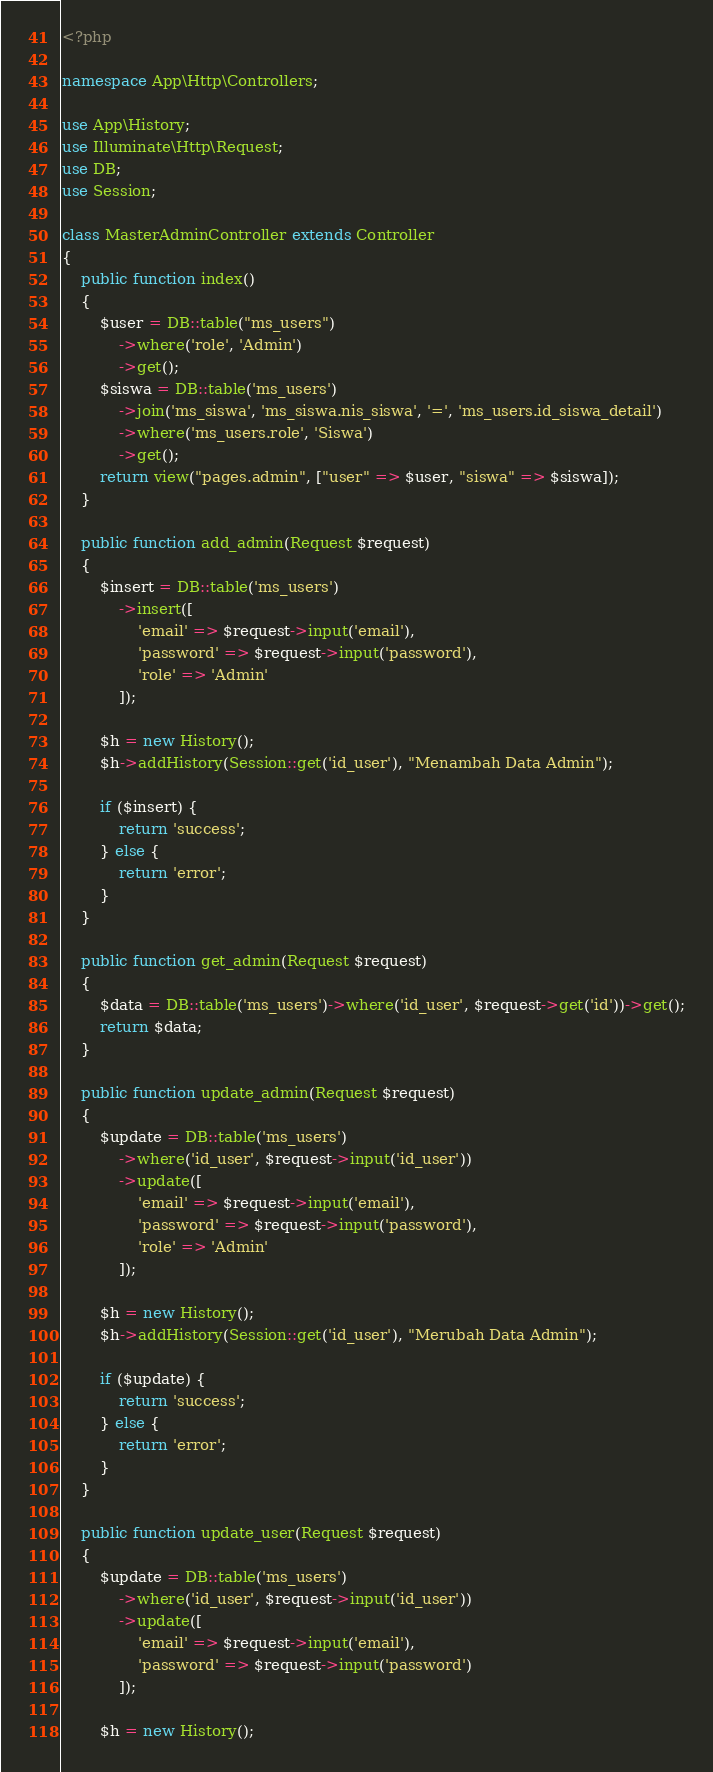Convert code to text. <code><loc_0><loc_0><loc_500><loc_500><_PHP_><?php

namespace App\Http\Controllers;

use App\History;
use Illuminate\Http\Request;
use DB;
use Session;

class MasterAdminController extends Controller
{
    public function index()
    {
        $user = DB::table("ms_users")
            ->where('role', 'Admin')
            ->get();
        $siswa = DB::table('ms_users')
            ->join('ms_siswa', 'ms_siswa.nis_siswa', '=', 'ms_users.id_siswa_detail')
            ->where('ms_users.role', 'Siswa')
            ->get();
        return view("pages.admin", ["user" => $user, "siswa" => $siswa]);
    }

    public function add_admin(Request $request)
    {
        $insert = DB::table('ms_users')
            ->insert([
                'email' => $request->input('email'),
                'password' => $request->input('password'),
                'role' => 'Admin'
            ]);

        $h = new History();
        $h->addHistory(Session::get('id_user'), "Menambah Data Admin");

        if ($insert) {
            return 'success';
        } else {
            return 'error';
        }
    }

    public function get_admin(Request $request)
    {
        $data = DB::table('ms_users')->where('id_user', $request->get('id'))->get();
        return $data;
    }

    public function update_admin(Request $request)
    {
        $update = DB::table('ms_users')
            ->where('id_user', $request->input('id_user'))
            ->update([
                'email' => $request->input('email'),
                'password' => $request->input('password'),
                'role' => 'Admin'
            ]);

        $h = new History();
        $h->addHistory(Session::get('id_user'), "Merubah Data Admin");

        if ($update) {
            return 'success';
        } else {
            return 'error';
        }
    }

    public function update_user(Request $request)
    {
        $update = DB::table('ms_users')
            ->where('id_user', $request->input('id_user'))
            ->update([
                'email' => $request->input('email'),
                'password' => $request->input('password')
            ]);

        $h = new History();</code> 